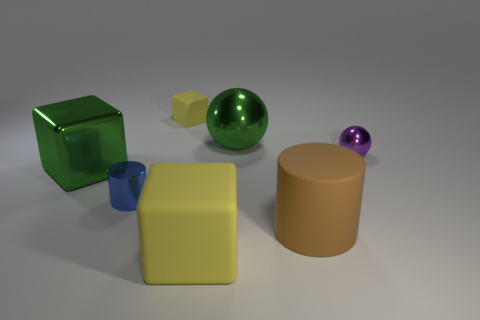Add 2 cyan cubes. How many objects exist? 9 Subtract all cubes. How many objects are left? 4 Add 3 brown matte objects. How many brown matte objects are left? 4 Add 2 big balls. How many big balls exist? 3 Subtract 0 yellow cylinders. How many objects are left? 7 Subtract all cyan blocks. Subtract all small yellow cubes. How many objects are left? 6 